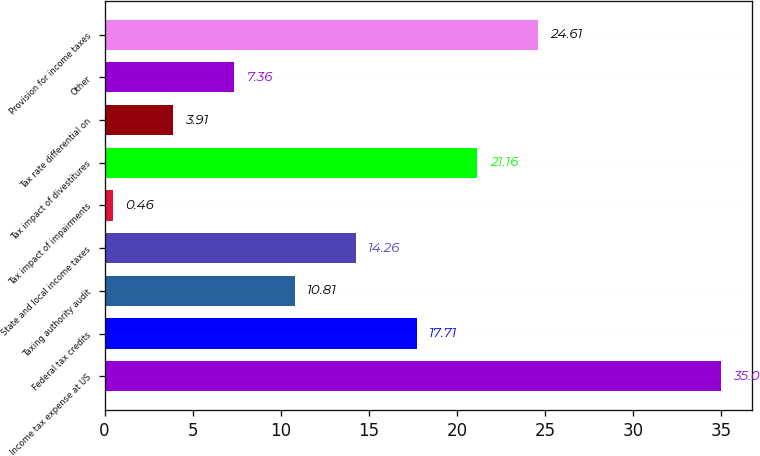Convert chart to OTSL. <chart><loc_0><loc_0><loc_500><loc_500><bar_chart><fcel>Income tax expense at US<fcel>Federal tax credits<fcel>Taxing authority audit<fcel>State and local income taxes<fcel>Tax impact of impairments<fcel>Tax impact of divestitures<fcel>Tax rate differential on<fcel>Other<fcel>Provision for income taxes<nl><fcel>35<fcel>17.71<fcel>10.81<fcel>14.26<fcel>0.46<fcel>21.16<fcel>3.91<fcel>7.36<fcel>24.61<nl></chart> 